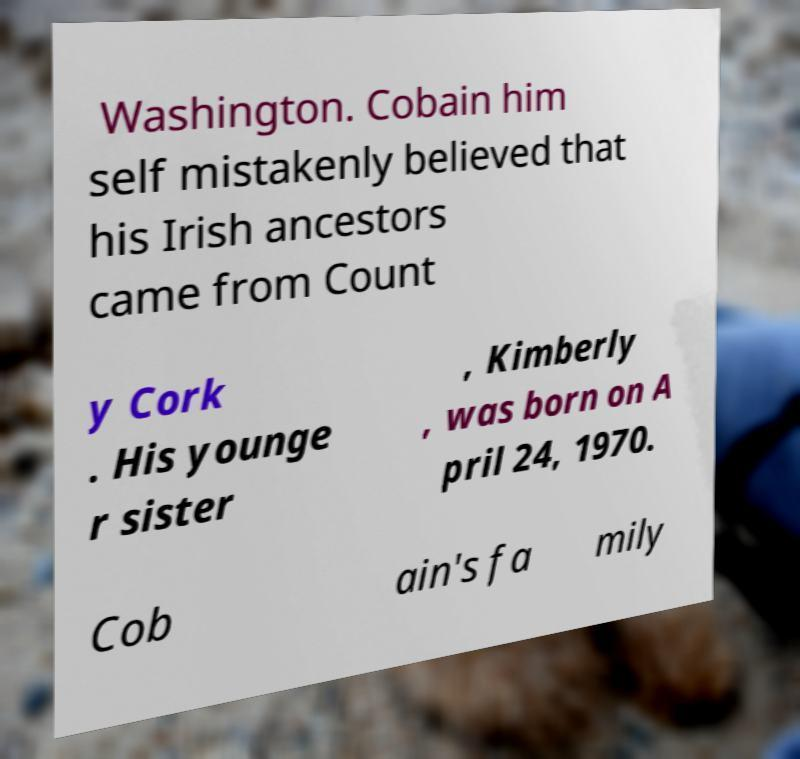Please read and relay the text visible in this image. What does it say? Washington. Cobain him self mistakenly believed that his Irish ancestors came from Count y Cork . His younge r sister , Kimberly , was born on A pril 24, 1970. Cob ain's fa mily 